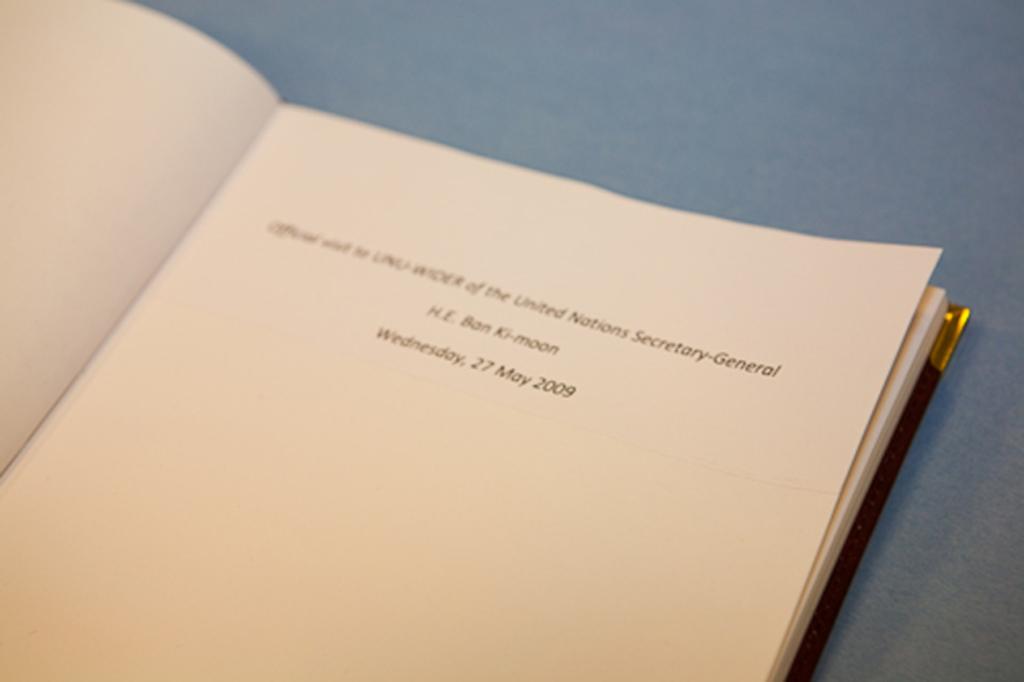What is the date on the last line?
Your response must be concise. 27 may 2009. 